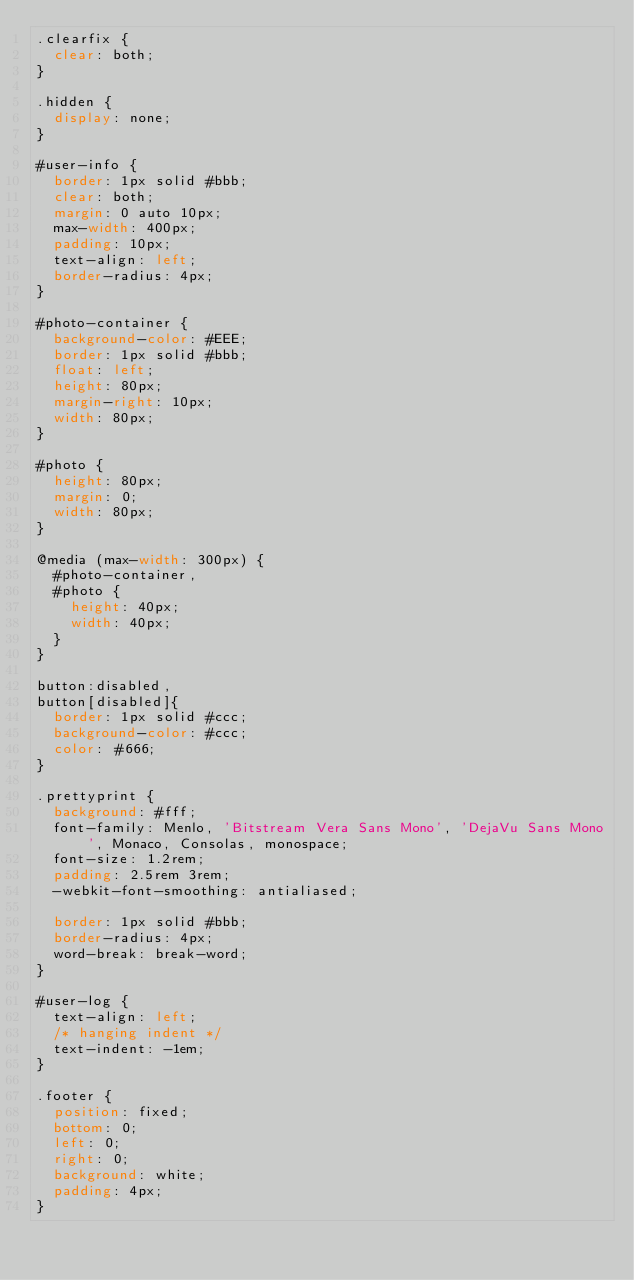Convert code to text. <code><loc_0><loc_0><loc_500><loc_500><_CSS_>.clearfix {
  clear: both;
}

.hidden {
  display: none;
}

#user-info {
  border: 1px solid #bbb;
  clear: both;
  margin: 0 auto 10px;
  max-width: 400px;
  padding: 10px;
  text-align: left;
  border-radius: 4px;
}

#photo-container {
  background-color: #EEE;
  border: 1px solid #bbb;
  float: left;
  height: 80px;
  margin-right: 10px;
  width: 80px;
}

#photo {
  height: 80px;
  margin: 0;
  width: 80px;
}

@media (max-width: 300px) {
  #photo-container,
  #photo {
    height: 40px;
    width: 40px;
  }
}

button:disabled,
button[disabled]{
  border: 1px solid #ccc;
  background-color: #ccc;
  color: #666;
}

.prettyprint {
  background: #fff;
  font-family: Menlo, 'Bitstream Vera Sans Mono', 'DejaVu Sans Mono', Monaco, Consolas, monospace;
  font-size: 1.2rem;
  padding: 2.5rem 3rem;
  -webkit-font-smoothing: antialiased; 

  border: 1px solid #bbb;
  border-radius: 4px;
  word-break: break-word;
}

#user-log {
  text-align: left;
  /* hanging indent */
  text-indent: -1em;
}

.footer {
  position: fixed;
  bottom: 0;
  left: 0;
  right: 0;
  background: white;
  padding: 4px;
}
</code> 